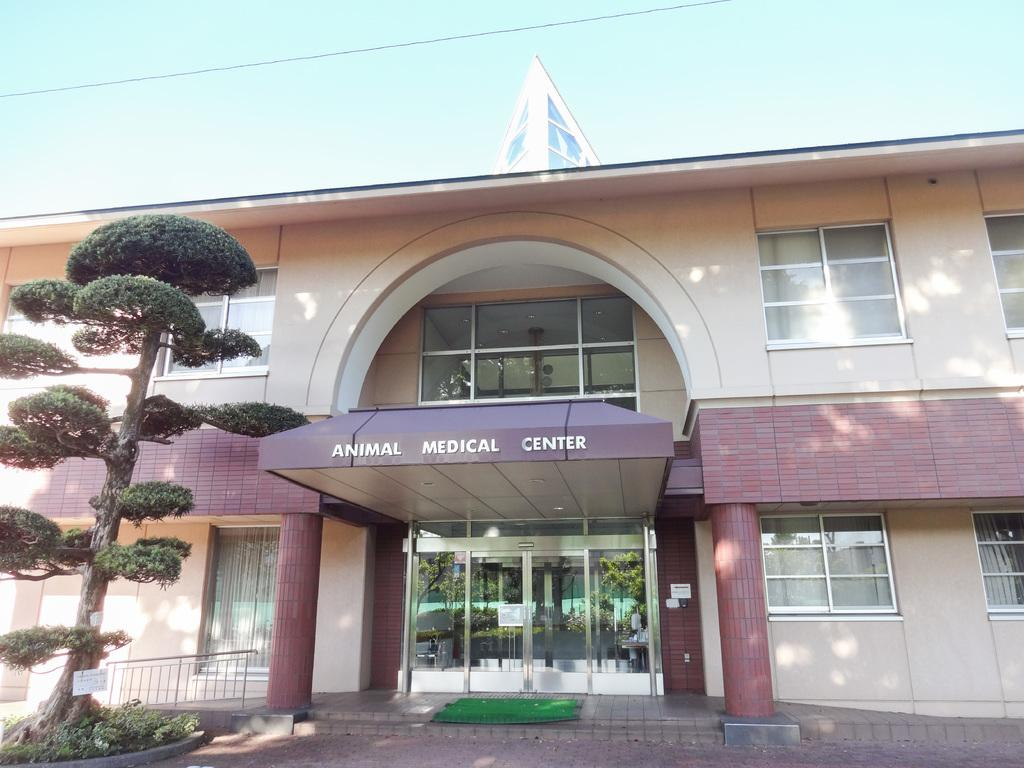Provide a one-sentence caption for the provided image. The Animal Medical Center is a big brown building. 